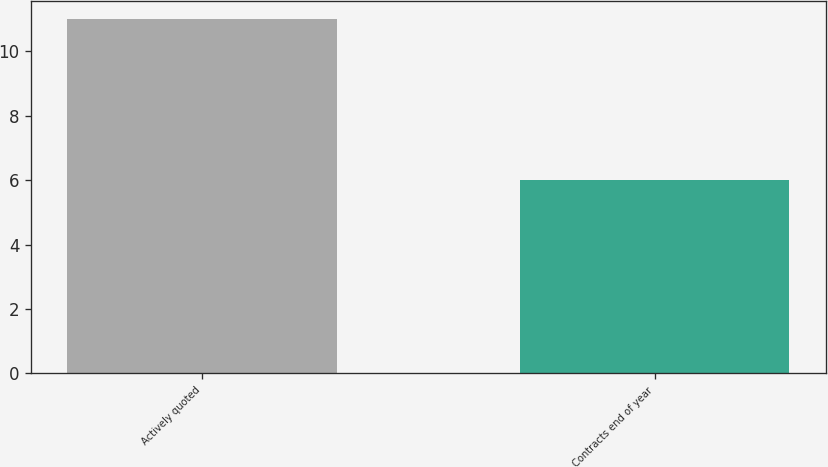Convert chart to OTSL. <chart><loc_0><loc_0><loc_500><loc_500><bar_chart><fcel>Actively quoted<fcel>Contracts end of year<nl><fcel>11<fcel>6<nl></chart> 